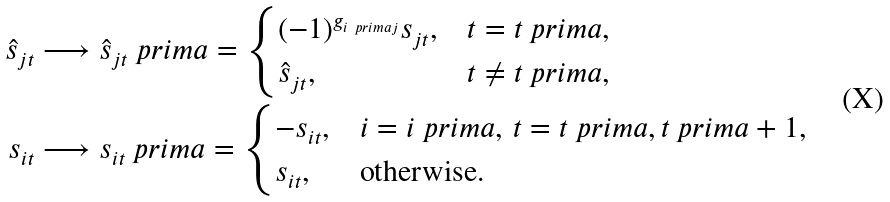<formula> <loc_0><loc_0><loc_500><loc_500>\hat { s } _ { j t } & \longrightarrow \hat { s } _ { j t } \ p r i m a = \begin{cases} ( - 1 ) ^ { g _ { i \ p r i m a j } } s _ { j t } , & t = t \ p r i m a , \\ \hat { s } _ { j t } , & t \neq t \ p r i m a , \end{cases} \\ s _ { i t } & \longrightarrow s _ { i t } \ p r i m a = \begin{cases} - s _ { i t } , & i = i \ p r i m a , \, t = t \ p r i m a , t \ p r i m a + 1 , \\ s _ { i t } , & \text {otherwise.} \end{cases}</formula> 